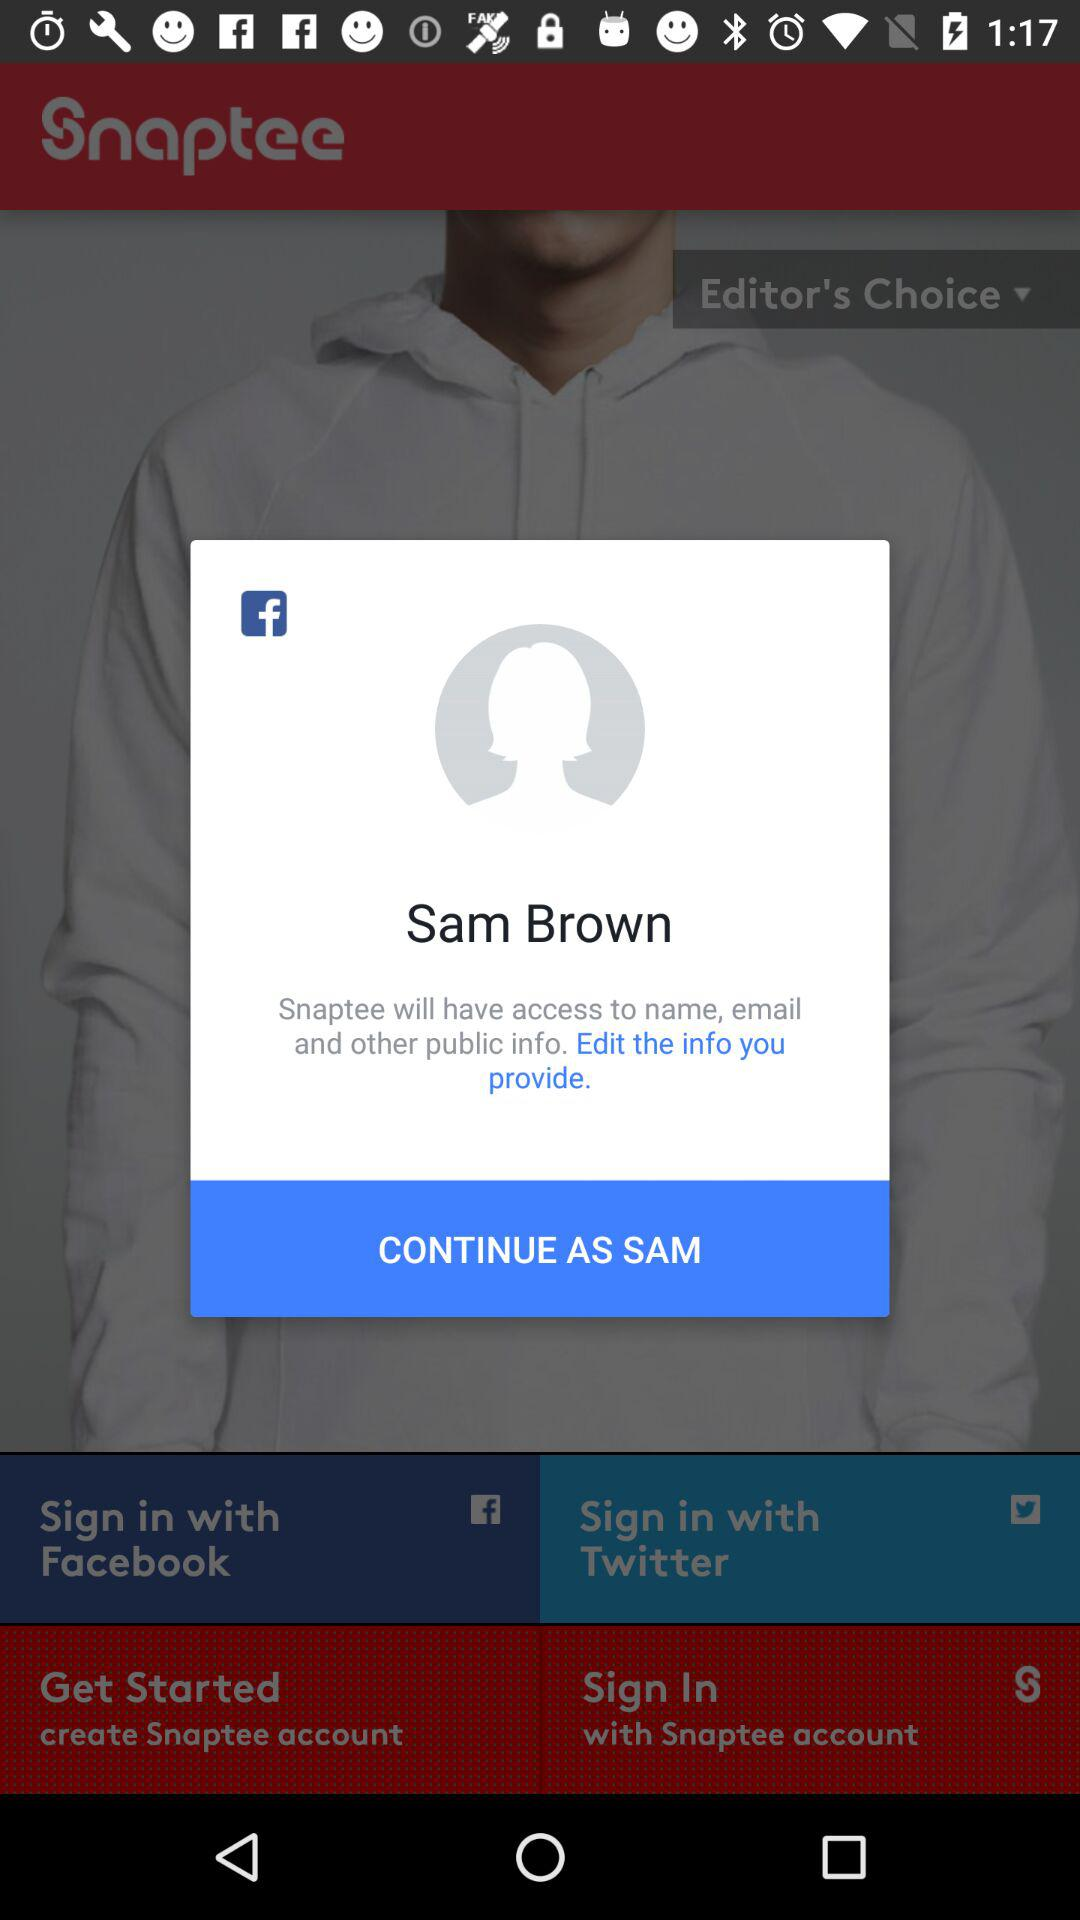What application is asking for permission? The application is "Snaptee". 